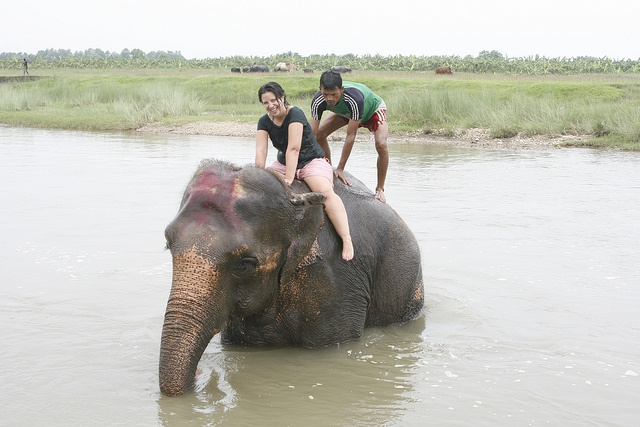Describe the objects in this image and their specific colors. I can see elephant in white, gray, black, and darkgray tones, people in white, lightgray, tan, black, and gray tones, people in white, gray, lightgray, and darkgray tones, and people in white, darkgray, gray, and lightgray tones in this image. 